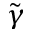Convert formula to latex. <formula><loc_0><loc_0><loc_500><loc_500>\tilde { \gamma }</formula> 